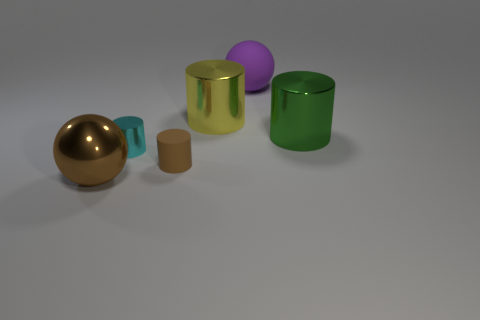There is a shiny ball that is the same color as the matte cylinder; what size is it?
Keep it short and to the point. Large. There is a large ball in front of the big green metal cylinder; what material is it?
Your answer should be compact. Metal. Are there an equal number of small cyan things that are in front of the big purple thing and large spheres behind the large yellow cylinder?
Your answer should be compact. Yes. There is a thing that is to the right of the large purple rubber object; does it have the same size as the rubber thing in front of the small cyan cylinder?
Your response must be concise. No. What number of other tiny things have the same color as the small matte object?
Ensure brevity in your answer.  0. There is a tiny thing that is the same color as the metallic ball; what material is it?
Keep it short and to the point. Rubber. Are there more matte cylinders on the right side of the brown shiny sphere than tiny balls?
Make the answer very short. Yes. Is the shape of the large brown metallic thing the same as the big matte object?
Provide a short and direct response. Yes. How many green objects have the same material as the large brown object?
Keep it short and to the point. 1. The cyan metallic thing that is the same shape as the small matte object is what size?
Provide a succinct answer. Small. 